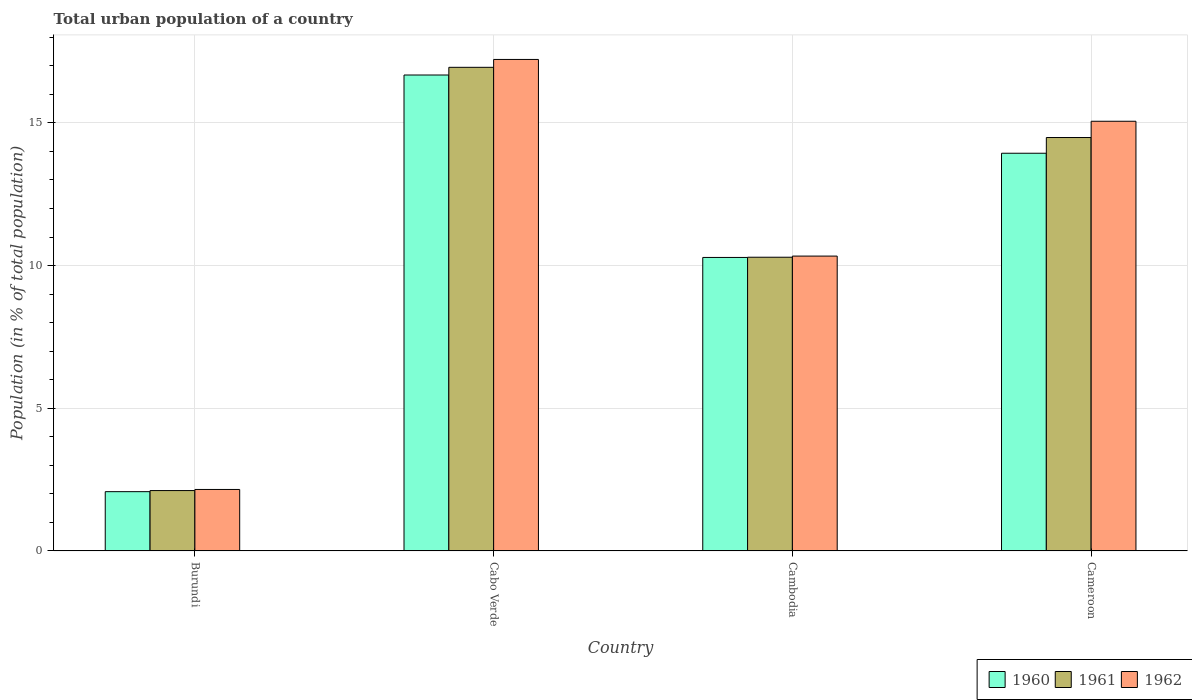How many groups of bars are there?
Ensure brevity in your answer.  4. Are the number of bars per tick equal to the number of legend labels?
Keep it short and to the point. Yes. Are the number of bars on each tick of the X-axis equal?
Provide a short and direct response. Yes. How many bars are there on the 2nd tick from the right?
Make the answer very short. 3. What is the label of the 2nd group of bars from the left?
Your answer should be very brief. Cabo Verde. What is the urban population in 1961 in Burundi?
Your answer should be very brief. 2.12. Across all countries, what is the maximum urban population in 1962?
Your response must be concise. 17.22. Across all countries, what is the minimum urban population in 1962?
Make the answer very short. 2.15. In which country was the urban population in 1960 maximum?
Make the answer very short. Cabo Verde. In which country was the urban population in 1960 minimum?
Offer a terse response. Burundi. What is the total urban population in 1962 in the graph?
Ensure brevity in your answer.  44.77. What is the difference between the urban population in 1960 in Burundi and that in Cambodia?
Your answer should be compact. -8.21. What is the difference between the urban population in 1961 in Cameroon and the urban population in 1962 in Cabo Verde?
Provide a succinct answer. -2.74. What is the average urban population in 1960 per country?
Make the answer very short. 10.74. What is the difference between the urban population of/in 1960 and urban population of/in 1961 in Cameroon?
Offer a very short reply. -0.55. In how many countries, is the urban population in 1962 greater than 12 %?
Your answer should be compact. 2. What is the ratio of the urban population in 1960 in Burundi to that in Cabo Verde?
Give a very brief answer. 0.12. Is the urban population in 1960 in Cabo Verde less than that in Cameroon?
Offer a very short reply. No. What is the difference between the highest and the second highest urban population in 1961?
Keep it short and to the point. 6.66. What is the difference between the highest and the lowest urban population in 1961?
Provide a short and direct response. 14.83. What does the 2nd bar from the left in Cameroon represents?
Provide a succinct answer. 1961. How many bars are there?
Offer a terse response. 12. Are all the bars in the graph horizontal?
Provide a succinct answer. No. What is the difference between two consecutive major ticks on the Y-axis?
Make the answer very short. 5. Are the values on the major ticks of Y-axis written in scientific E-notation?
Your response must be concise. No. Where does the legend appear in the graph?
Ensure brevity in your answer.  Bottom right. How are the legend labels stacked?
Your answer should be compact. Horizontal. What is the title of the graph?
Make the answer very short. Total urban population of a country. What is the label or title of the X-axis?
Your answer should be compact. Country. What is the label or title of the Y-axis?
Offer a very short reply. Population (in % of total population). What is the Population (in % of total population) in 1960 in Burundi?
Your answer should be very brief. 2.08. What is the Population (in % of total population) of 1961 in Burundi?
Your answer should be very brief. 2.12. What is the Population (in % of total population) of 1962 in Burundi?
Provide a succinct answer. 2.15. What is the Population (in % of total population) of 1960 in Cabo Verde?
Ensure brevity in your answer.  16.68. What is the Population (in % of total population) of 1961 in Cabo Verde?
Provide a succinct answer. 16.95. What is the Population (in % of total population) in 1962 in Cabo Verde?
Offer a very short reply. 17.22. What is the Population (in % of total population) in 1960 in Cambodia?
Offer a terse response. 10.29. What is the Population (in % of total population) in 1961 in Cambodia?
Your answer should be very brief. 10.29. What is the Population (in % of total population) in 1962 in Cambodia?
Provide a succinct answer. 10.33. What is the Population (in % of total population) of 1960 in Cameroon?
Offer a terse response. 13.94. What is the Population (in % of total population) in 1961 in Cameroon?
Provide a short and direct response. 14.49. What is the Population (in % of total population) in 1962 in Cameroon?
Ensure brevity in your answer.  15.06. Across all countries, what is the maximum Population (in % of total population) of 1960?
Your answer should be very brief. 16.68. Across all countries, what is the maximum Population (in % of total population) of 1961?
Give a very brief answer. 16.95. Across all countries, what is the maximum Population (in % of total population) in 1962?
Give a very brief answer. 17.22. Across all countries, what is the minimum Population (in % of total population) of 1960?
Offer a terse response. 2.08. Across all countries, what is the minimum Population (in % of total population) in 1961?
Make the answer very short. 2.12. Across all countries, what is the minimum Population (in % of total population) in 1962?
Offer a terse response. 2.15. What is the total Population (in % of total population) in 1960 in the graph?
Your answer should be compact. 42.98. What is the total Population (in % of total population) of 1961 in the graph?
Offer a very short reply. 43.84. What is the total Population (in % of total population) of 1962 in the graph?
Your response must be concise. 44.77. What is the difference between the Population (in % of total population) of 1960 in Burundi and that in Cabo Verde?
Make the answer very short. -14.6. What is the difference between the Population (in % of total population) in 1961 in Burundi and that in Cabo Verde?
Provide a short and direct response. -14.83. What is the difference between the Population (in % of total population) of 1962 in Burundi and that in Cabo Verde?
Provide a short and direct response. -15.07. What is the difference between the Population (in % of total population) of 1960 in Burundi and that in Cambodia?
Give a very brief answer. -8.21. What is the difference between the Population (in % of total population) in 1961 in Burundi and that in Cambodia?
Your answer should be very brief. -8.18. What is the difference between the Population (in % of total population) of 1962 in Burundi and that in Cambodia?
Your answer should be compact. -8.18. What is the difference between the Population (in % of total population) of 1960 in Burundi and that in Cameroon?
Provide a short and direct response. -11.86. What is the difference between the Population (in % of total population) of 1961 in Burundi and that in Cameroon?
Provide a short and direct response. -12.37. What is the difference between the Population (in % of total population) of 1962 in Burundi and that in Cameroon?
Provide a succinct answer. -12.9. What is the difference between the Population (in % of total population) of 1960 in Cabo Verde and that in Cambodia?
Offer a very short reply. 6.39. What is the difference between the Population (in % of total population) in 1961 in Cabo Verde and that in Cambodia?
Your answer should be compact. 6.66. What is the difference between the Population (in % of total population) of 1962 in Cabo Verde and that in Cambodia?
Offer a very short reply. 6.89. What is the difference between the Population (in % of total population) of 1960 in Cabo Verde and that in Cameroon?
Ensure brevity in your answer.  2.74. What is the difference between the Population (in % of total population) in 1961 in Cabo Verde and that in Cameroon?
Provide a succinct answer. 2.46. What is the difference between the Population (in % of total population) of 1962 in Cabo Verde and that in Cameroon?
Provide a short and direct response. 2.17. What is the difference between the Population (in % of total population) of 1960 in Cambodia and that in Cameroon?
Give a very brief answer. -3.65. What is the difference between the Population (in % of total population) of 1961 in Cambodia and that in Cameroon?
Ensure brevity in your answer.  -4.2. What is the difference between the Population (in % of total population) of 1962 in Cambodia and that in Cameroon?
Your answer should be compact. -4.72. What is the difference between the Population (in % of total population) in 1960 in Burundi and the Population (in % of total population) in 1961 in Cabo Verde?
Provide a succinct answer. -14.87. What is the difference between the Population (in % of total population) in 1960 in Burundi and the Population (in % of total population) in 1962 in Cabo Verde?
Make the answer very short. -15.15. What is the difference between the Population (in % of total population) in 1961 in Burundi and the Population (in % of total population) in 1962 in Cabo Verde?
Your answer should be very brief. -15.11. What is the difference between the Population (in % of total population) in 1960 in Burundi and the Population (in % of total population) in 1961 in Cambodia?
Keep it short and to the point. -8.22. What is the difference between the Population (in % of total population) of 1960 in Burundi and the Population (in % of total population) of 1962 in Cambodia?
Provide a succinct answer. -8.26. What is the difference between the Population (in % of total population) in 1961 in Burundi and the Population (in % of total population) in 1962 in Cambodia?
Ensure brevity in your answer.  -8.22. What is the difference between the Population (in % of total population) of 1960 in Burundi and the Population (in % of total population) of 1961 in Cameroon?
Keep it short and to the point. -12.41. What is the difference between the Population (in % of total population) in 1960 in Burundi and the Population (in % of total population) in 1962 in Cameroon?
Offer a terse response. -12.98. What is the difference between the Population (in % of total population) in 1961 in Burundi and the Population (in % of total population) in 1962 in Cameroon?
Offer a very short reply. -12.94. What is the difference between the Population (in % of total population) of 1960 in Cabo Verde and the Population (in % of total population) of 1961 in Cambodia?
Provide a succinct answer. 6.39. What is the difference between the Population (in % of total population) of 1960 in Cabo Verde and the Population (in % of total population) of 1962 in Cambodia?
Ensure brevity in your answer.  6.35. What is the difference between the Population (in % of total population) in 1961 in Cabo Verde and the Population (in % of total population) in 1962 in Cambodia?
Give a very brief answer. 6.62. What is the difference between the Population (in % of total population) in 1960 in Cabo Verde and the Population (in % of total population) in 1961 in Cameroon?
Make the answer very short. 2.19. What is the difference between the Population (in % of total population) in 1960 in Cabo Verde and the Population (in % of total population) in 1962 in Cameroon?
Keep it short and to the point. 1.62. What is the difference between the Population (in % of total population) in 1961 in Cabo Verde and the Population (in % of total population) in 1962 in Cameroon?
Your response must be concise. 1.89. What is the difference between the Population (in % of total population) of 1960 in Cambodia and the Population (in % of total population) of 1961 in Cameroon?
Offer a terse response. -4.2. What is the difference between the Population (in % of total population) of 1960 in Cambodia and the Population (in % of total population) of 1962 in Cameroon?
Your response must be concise. -4.77. What is the difference between the Population (in % of total population) of 1961 in Cambodia and the Population (in % of total population) of 1962 in Cameroon?
Your response must be concise. -4.76. What is the average Population (in % of total population) of 1960 per country?
Offer a very short reply. 10.74. What is the average Population (in % of total population) of 1961 per country?
Offer a terse response. 10.96. What is the average Population (in % of total population) in 1962 per country?
Provide a short and direct response. 11.19. What is the difference between the Population (in % of total population) of 1960 and Population (in % of total population) of 1961 in Burundi?
Give a very brief answer. -0.04. What is the difference between the Population (in % of total population) of 1960 and Population (in % of total population) of 1962 in Burundi?
Your answer should be compact. -0.08. What is the difference between the Population (in % of total population) of 1961 and Population (in % of total population) of 1962 in Burundi?
Offer a terse response. -0.04. What is the difference between the Population (in % of total population) in 1960 and Population (in % of total population) in 1961 in Cabo Verde?
Provide a short and direct response. -0.27. What is the difference between the Population (in % of total population) of 1960 and Population (in % of total population) of 1962 in Cabo Verde?
Provide a succinct answer. -0.55. What is the difference between the Population (in % of total population) of 1961 and Population (in % of total population) of 1962 in Cabo Verde?
Give a very brief answer. -0.28. What is the difference between the Population (in % of total population) of 1960 and Population (in % of total population) of 1961 in Cambodia?
Give a very brief answer. -0.01. What is the difference between the Population (in % of total population) in 1960 and Population (in % of total population) in 1962 in Cambodia?
Make the answer very short. -0.05. What is the difference between the Population (in % of total population) of 1961 and Population (in % of total population) of 1962 in Cambodia?
Your answer should be compact. -0.04. What is the difference between the Population (in % of total population) in 1960 and Population (in % of total population) in 1961 in Cameroon?
Your answer should be compact. -0.55. What is the difference between the Population (in % of total population) of 1960 and Population (in % of total population) of 1962 in Cameroon?
Make the answer very short. -1.12. What is the difference between the Population (in % of total population) of 1961 and Population (in % of total population) of 1962 in Cameroon?
Offer a very short reply. -0.57. What is the ratio of the Population (in % of total population) of 1960 in Burundi to that in Cabo Verde?
Your response must be concise. 0.12. What is the ratio of the Population (in % of total population) in 1961 in Burundi to that in Cabo Verde?
Offer a very short reply. 0.12. What is the ratio of the Population (in % of total population) of 1962 in Burundi to that in Cabo Verde?
Offer a very short reply. 0.13. What is the ratio of the Population (in % of total population) of 1960 in Burundi to that in Cambodia?
Your response must be concise. 0.2. What is the ratio of the Population (in % of total population) in 1961 in Burundi to that in Cambodia?
Ensure brevity in your answer.  0.21. What is the ratio of the Population (in % of total population) in 1962 in Burundi to that in Cambodia?
Your answer should be very brief. 0.21. What is the ratio of the Population (in % of total population) in 1960 in Burundi to that in Cameroon?
Ensure brevity in your answer.  0.15. What is the ratio of the Population (in % of total population) in 1961 in Burundi to that in Cameroon?
Your answer should be compact. 0.15. What is the ratio of the Population (in % of total population) in 1962 in Burundi to that in Cameroon?
Provide a succinct answer. 0.14. What is the ratio of the Population (in % of total population) in 1960 in Cabo Verde to that in Cambodia?
Your answer should be compact. 1.62. What is the ratio of the Population (in % of total population) in 1961 in Cabo Verde to that in Cambodia?
Provide a succinct answer. 1.65. What is the ratio of the Population (in % of total population) of 1962 in Cabo Verde to that in Cambodia?
Give a very brief answer. 1.67. What is the ratio of the Population (in % of total population) of 1960 in Cabo Verde to that in Cameroon?
Your answer should be compact. 1.2. What is the ratio of the Population (in % of total population) of 1961 in Cabo Verde to that in Cameroon?
Provide a succinct answer. 1.17. What is the ratio of the Population (in % of total population) in 1962 in Cabo Verde to that in Cameroon?
Keep it short and to the point. 1.14. What is the ratio of the Population (in % of total population) in 1960 in Cambodia to that in Cameroon?
Your answer should be very brief. 0.74. What is the ratio of the Population (in % of total population) in 1961 in Cambodia to that in Cameroon?
Ensure brevity in your answer.  0.71. What is the ratio of the Population (in % of total population) in 1962 in Cambodia to that in Cameroon?
Keep it short and to the point. 0.69. What is the difference between the highest and the second highest Population (in % of total population) of 1960?
Your answer should be very brief. 2.74. What is the difference between the highest and the second highest Population (in % of total population) in 1961?
Offer a terse response. 2.46. What is the difference between the highest and the second highest Population (in % of total population) of 1962?
Keep it short and to the point. 2.17. What is the difference between the highest and the lowest Population (in % of total population) of 1960?
Your answer should be compact. 14.6. What is the difference between the highest and the lowest Population (in % of total population) of 1961?
Your response must be concise. 14.83. What is the difference between the highest and the lowest Population (in % of total population) in 1962?
Provide a succinct answer. 15.07. 